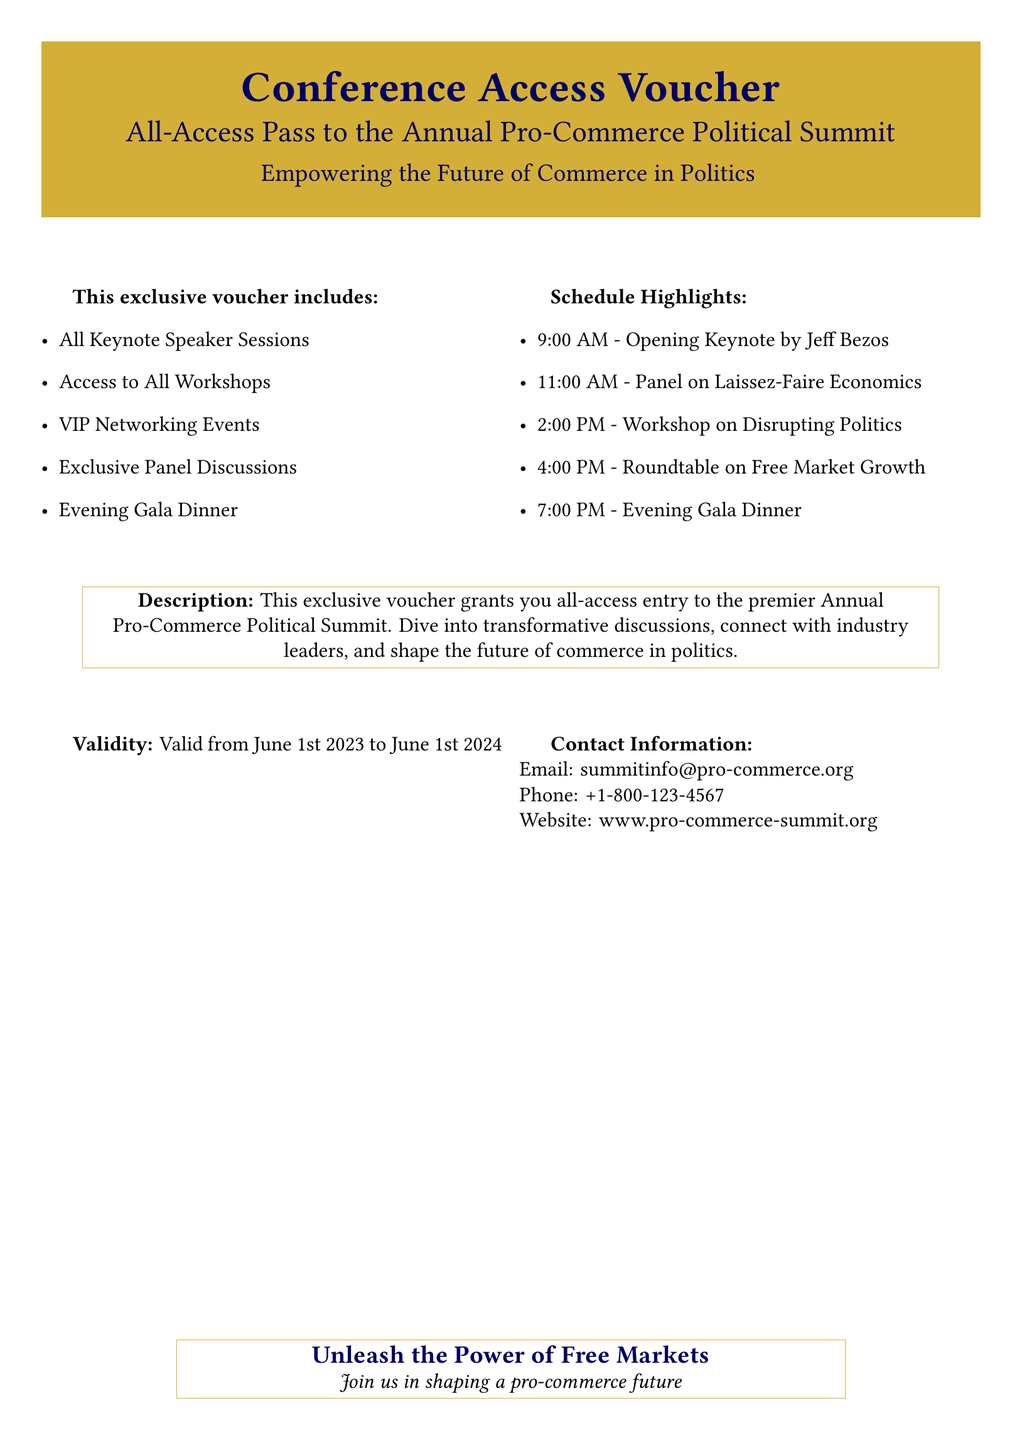What is the title of the conference? The title of the conference is explicitly stated in the document under the voucher title.
Answer: Conference Access Voucher Who is the opening keynote speaker? The document specifies the opening keynote speaker in the schedule highlights section.
Answer: Jeff Bezos What is included in the exclusive voucher? The document lists several items included in the exclusive voucher, found in the section that outlines the voucher contents.
Answer: All Keynote Speaker Sessions What time does the Evening Gala Dinner start? The time for the Evening Gala Dinner is part of the schedule highlights in the document.
Answer: 7:00 PM What is the validity period of the voucher? The validity period is explicitly mentioned in the document under the validity section.
Answer: June 1st 2023 to June 1st 2024 What type of event is hosted at 2:00 PM? The type of event at 2:00 PM can be found in the schedule highlights section of the document.
Answer: Workshop on Disrupting Politics What is the contact email provided? The contact email can be retrieved from the contact information section in the document.
Answer: summitinfo@pro-commerce.org What is the theme of the conference mentioned at the bottom? The theme of the conference is indicated in the concluding statement within the document.
Answer: Pro-commerce future 